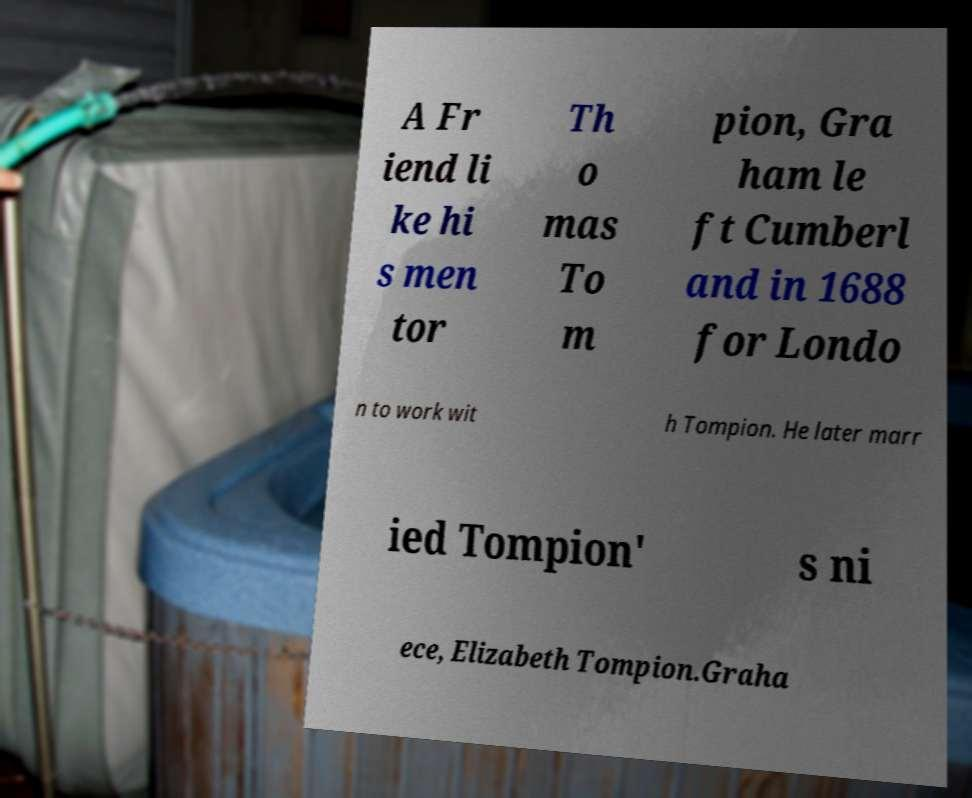Could you extract and type out the text from this image? A Fr iend li ke hi s men tor Th o mas To m pion, Gra ham le ft Cumberl and in 1688 for Londo n to work wit h Tompion. He later marr ied Tompion' s ni ece, Elizabeth Tompion.Graha 